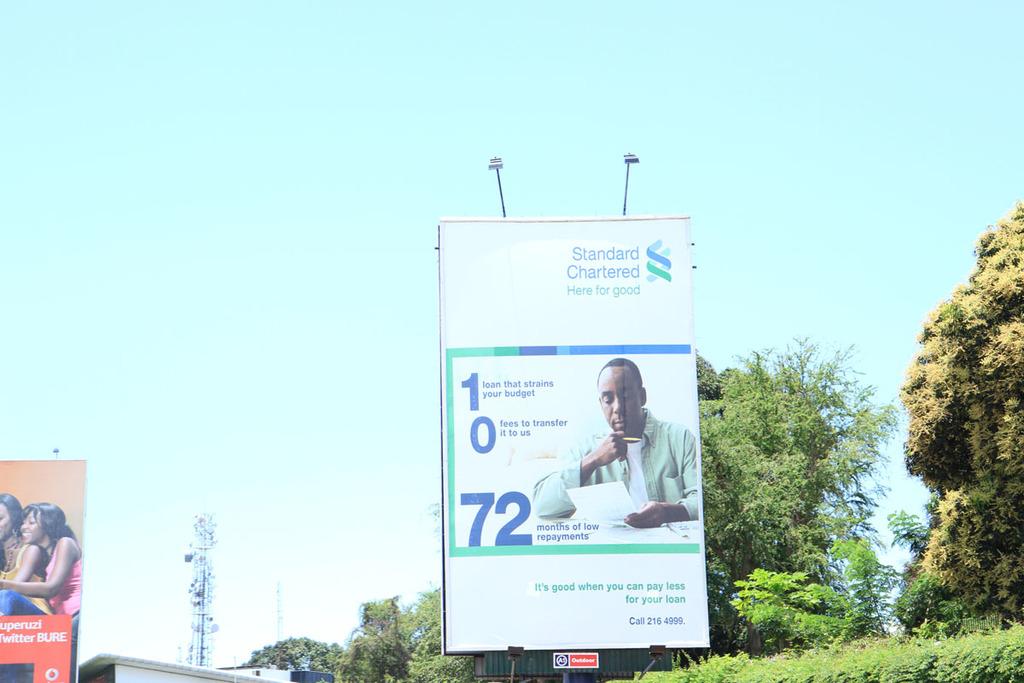How many months of repayments are in the ad?
Your response must be concise. 72. 